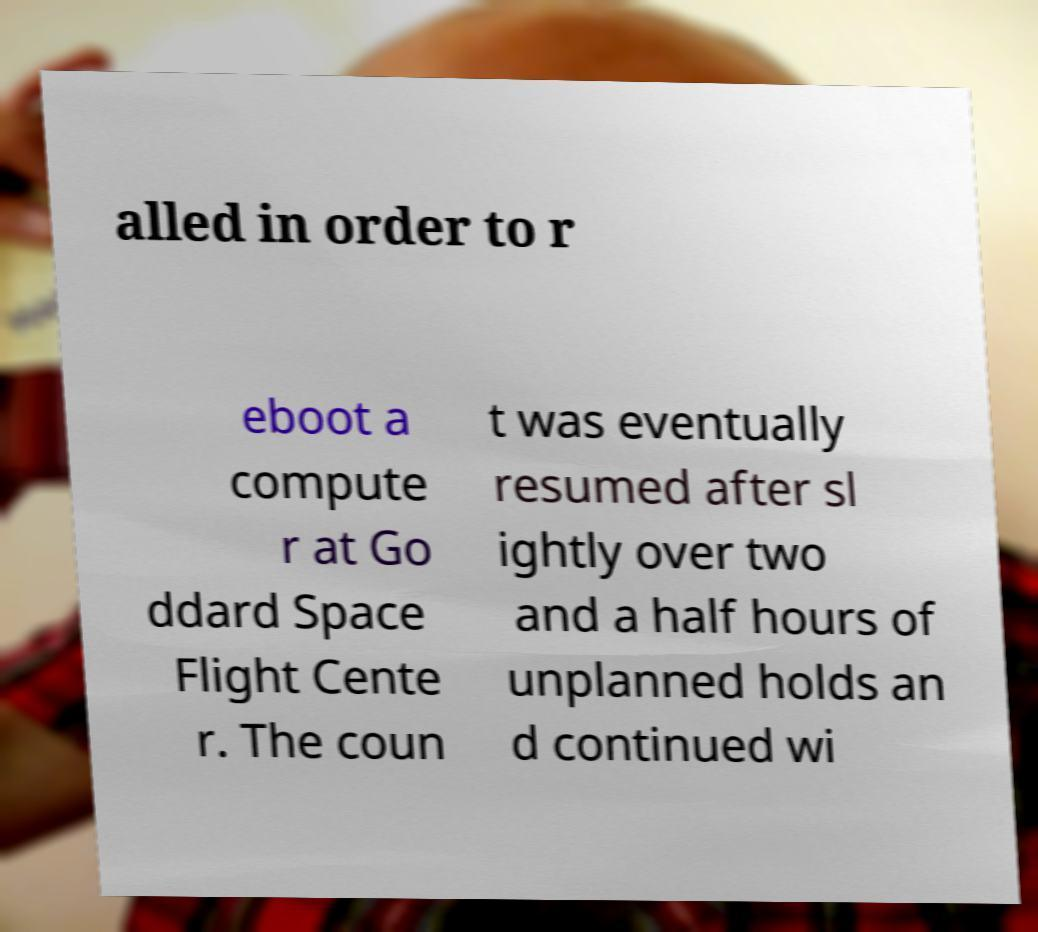There's text embedded in this image that I need extracted. Can you transcribe it verbatim? alled in order to r eboot a compute r at Go ddard Space Flight Cente r. The coun t was eventually resumed after sl ightly over two and a half hours of unplanned holds an d continued wi 